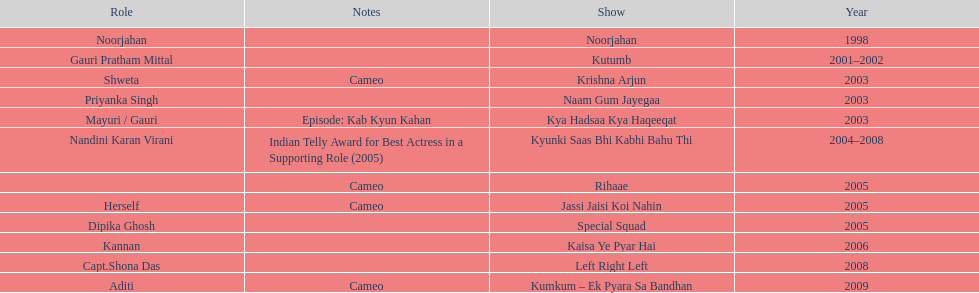Which television show was gauri in for the longest amount of time? Kyunki Saas Bhi Kabhi Bahu Thi. 